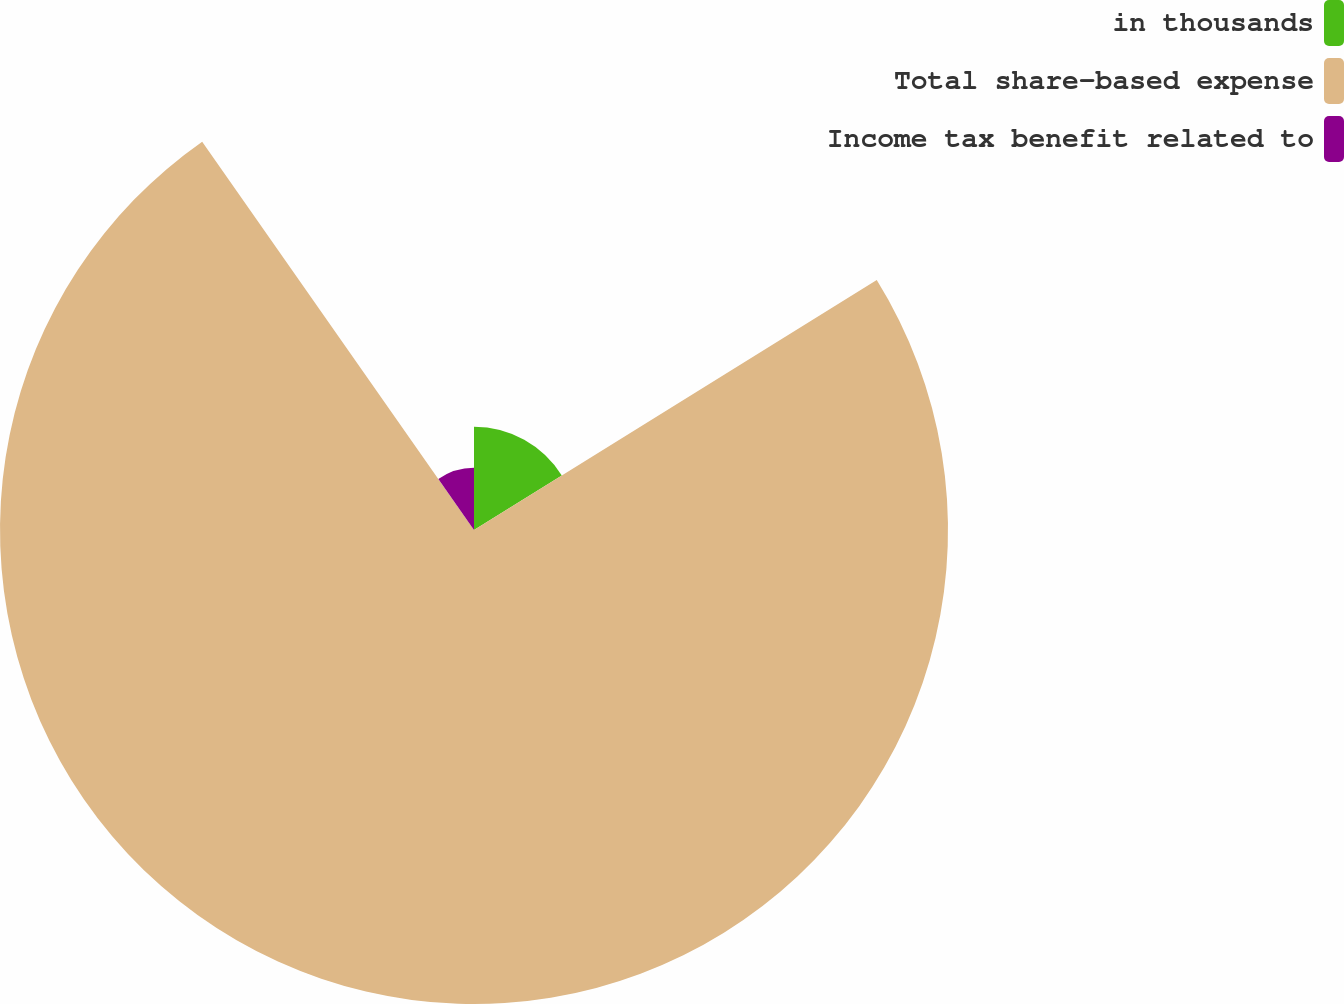Convert chart. <chart><loc_0><loc_0><loc_500><loc_500><pie_chart><fcel>in thousands<fcel>Total share-based expense<fcel>Income tax benefit related to<nl><fcel>16.16%<fcel>74.12%<fcel>9.72%<nl></chart> 